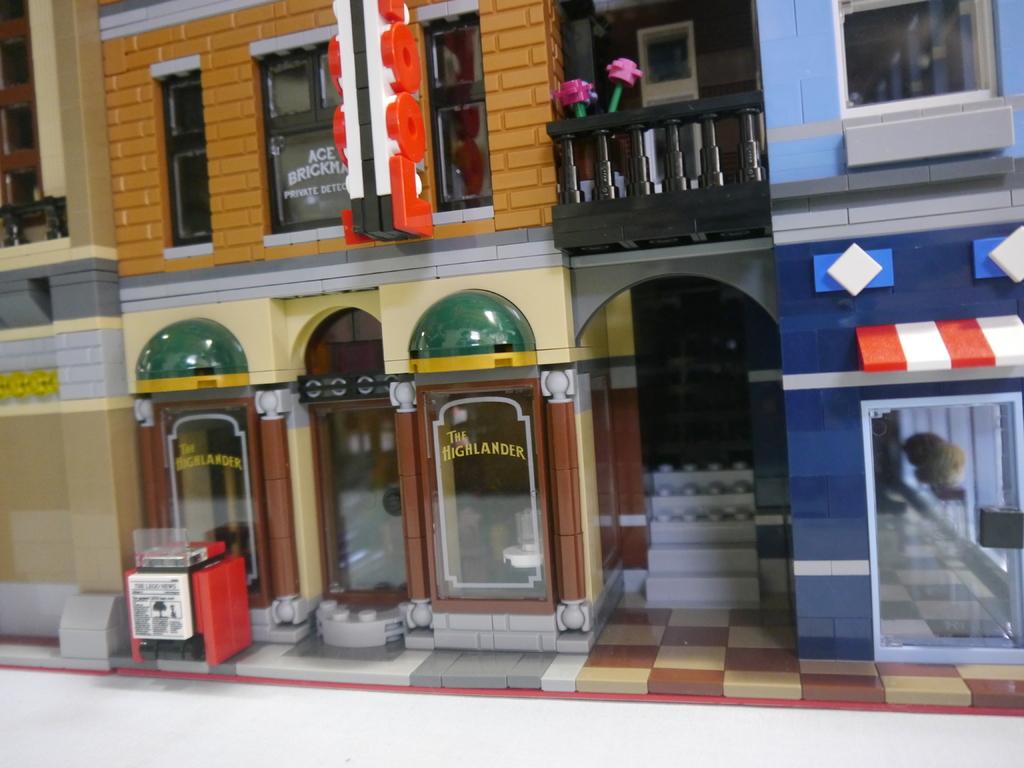Who is the private detective on the second floor?
Offer a very short reply. Ace brickman. What is written on the bottom window?
Make the answer very short. The highlander. 